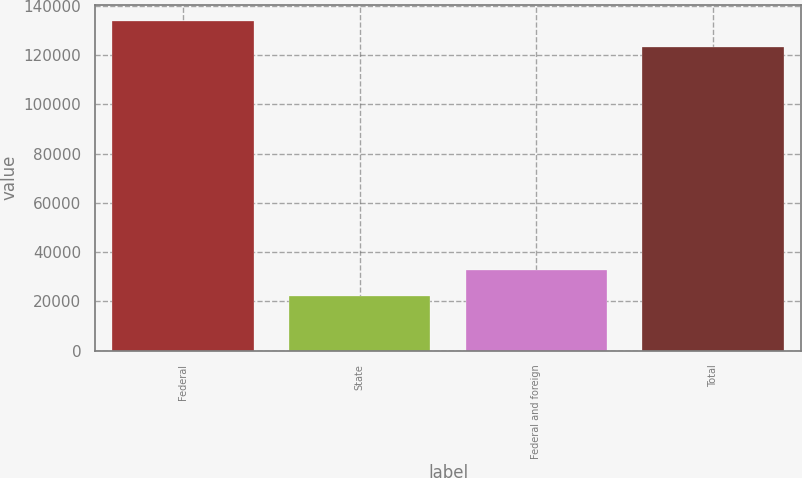<chart> <loc_0><loc_0><loc_500><loc_500><bar_chart><fcel>Federal<fcel>State<fcel>Federal and foreign<fcel>Total<nl><fcel>133777<fcel>22230<fcel>32629.2<fcel>123378<nl></chart> 